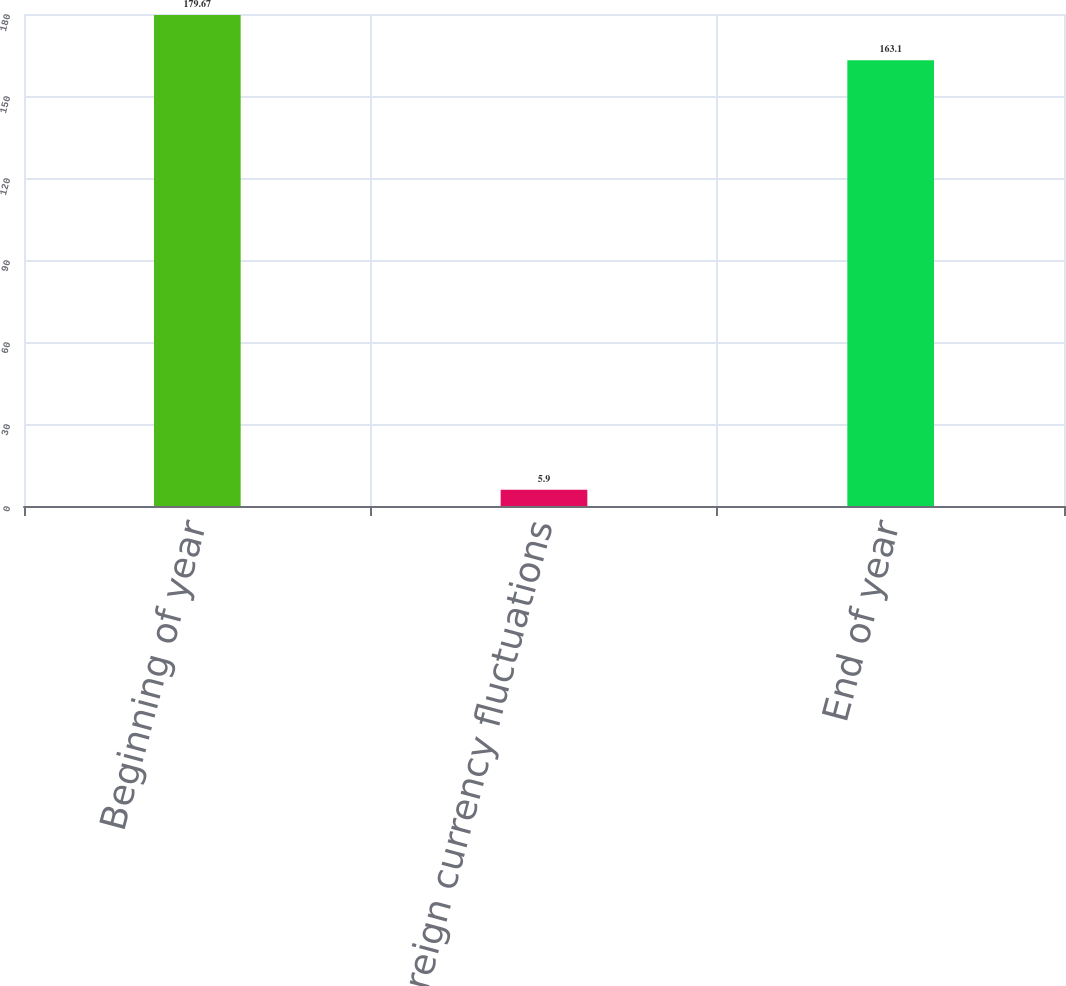<chart> <loc_0><loc_0><loc_500><loc_500><bar_chart><fcel>Beginning of year<fcel>Foreign currency fluctuations<fcel>End of year<nl><fcel>179.67<fcel>5.9<fcel>163.1<nl></chart> 